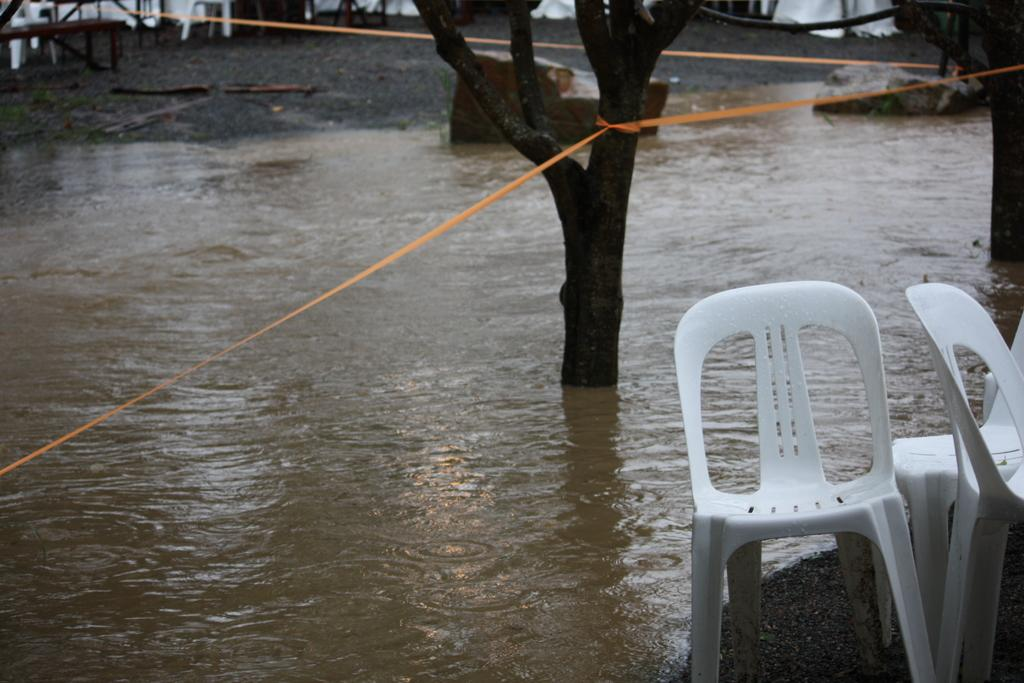What type of furniture is on the right side of the image? There are white color chairs on the right side of the image. What is the main subject in the middle of the image? There is a tree in the water in the middle of the image. What is attached to the tree in the image? There are orange color ropes tied to the tree. What type of pump can be seen near the tree in the image? There is no pump present near the tree in the image. What color is the yarn used to tie the ropes to the tree? There is no yarn present in the image; the ropes are orange in color. 